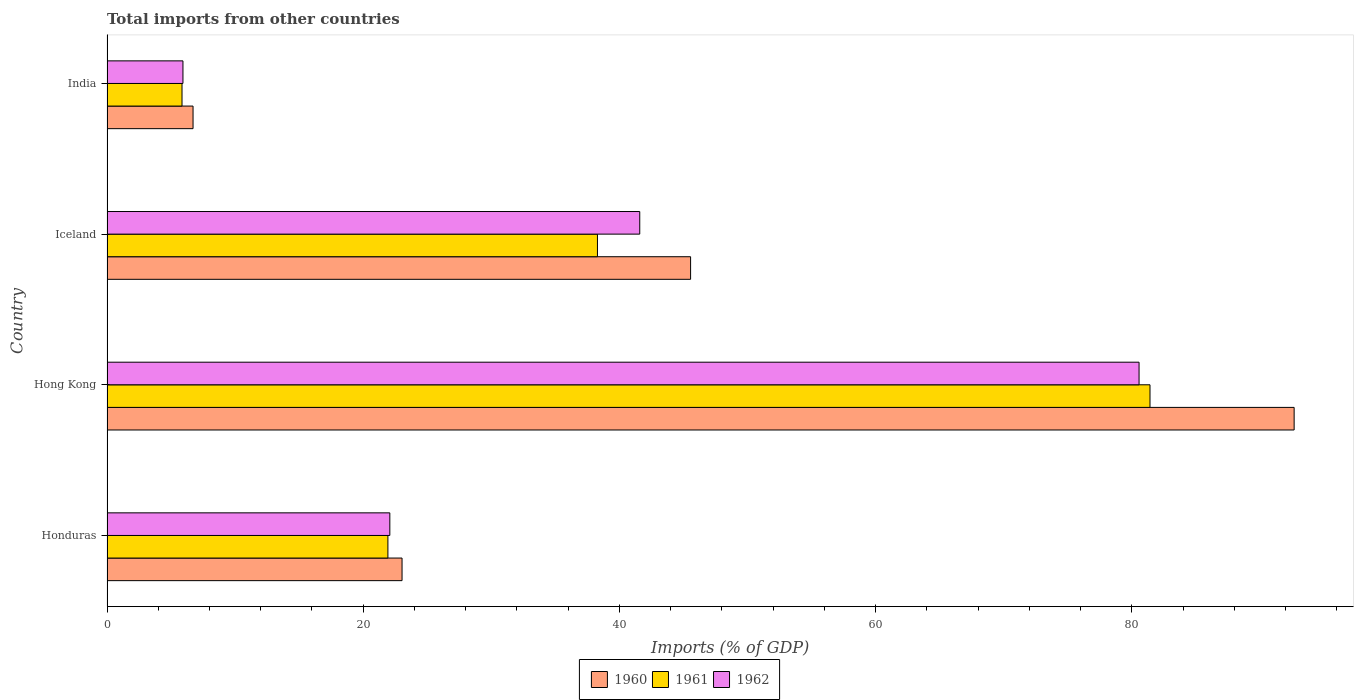How many groups of bars are there?
Offer a very short reply. 4. In how many cases, is the number of bars for a given country not equal to the number of legend labels?
Give a very brief answer. 0. What is the total imports in 1960 in India?
Offer a very short reply. 6.72. Across all countries, what is the maximum total imports in 1960?
Keep it short and to the point. 92.66. Across all countries, what is the minimum total imports in 1961?
Your answer should be compact. 5.85. In which country was the total imports in 1962 maximum?
Offer a terse response. Hong Kong. What is the total total imports in 1961 in the graph?
Your answer should be very brief. 147.48. What is the difference between the total imports in 1962 in Honduras and that in India?
Give a very brief answer. 16.15. What is the difference between the total imports in 1962 in India and the total imports in 1960 in Honduras?
Ensure brevity in your answer.  -17.1. What is the average total imports in 1960 per country?
Your answer should be very brief. 41.99. What is the difference between the total imports in 1961 and total imports in 1962 in India?
Offer a terse response. -0.07. In how many countries, is the total imports in 1960 greater than 36 %?
Provide a short and direct response. 2. What is the ratio of the total imports in 1962 in Honduras to that in Iceland?
Make the answer very short. 0.53. Is the difference between the total imports in 1961 in Hong Kong and Iceland greater than the difference between the total imports in 1962 in Hong Kong and Iceland?
Your answer should be compact. Yes. What is the difference between the highest and the second highest total imports in 1962?
Provide a succinct answer. 38.97. What is the difference between the highest and the lowest total imports in 1962?
Make the answer very short. 74.63. What does the 3rd bar from the top in Hong Kong represents?
Offer a very short reply. 1960. Is it the case that in every country, the sum of the total imports in 1961 and total imports in 1960 is greater than the total imports in 1962?
Your response must be concise. Yes. How many bars are there?
Offer a very short reply. 12. Are all the bars in the graph horizontal?
Give a very brief answer. Yes. How many legend labels are there?
Provide a succinct answer. 3. How are the legend labels stacked?
Ensure brevity in your answer.  Horizontal. What is the title of the graph?
Make the answer very short. Total imports from other countries. Does "1982" appear as one of the legend labels in the graph?
Provide a short and direct response. No. What is the label or title of the X-axis?
Your answer should be very brief. Imports (% of GDP). What is the Imports (% of GDP) in 1960 in Honduras?
Provide a succinct answer. 23.03. What is the Imports (% of GDP) of 1961 in Honduras?
Ensure brevity in your answer.  21.93. What is the Imports (% of GDP) in 1962 in Honduras?
Make the answer very short. 22.08. What is the Imports (% of GDP) in 1960 in Hong Kong?
Keep it short and to the point. 92.66. What is the Imports (% of GDP) of 1961 in Hong Kong?
Ensure brevity in your answer.  81.41. What is the Imports (% of GDP) in 1962 in Hong Kong?
Your response must be concise. 80.56. What is the Imports (% of GDP) of 1960 in Iceland?
Ensure brevity in your answer.  45.55. What is the Imports (% of GDP) of 1961 in Iceland?
Provide a short and direct response. 38.28. What is the Imports (% of GDP) of 1962 in Iceland?
Offer a very short reply. 41.58. What is the Imports (% of GDP) in 1960 in India?
Keep it short and to the point. 6.72. What is the Imports (% of GDP) of 1961 in India?
Your answer should be very brief. 5.85. What is the Imports (% of GDP) of 1962 in India?
Your answer should be compact. 5.93. Across all countries, what is the maximum Imports (% of GDP) in 1960?
Provide a short and direct response. 92.66. Across all countries, what is the maximum Imports (% of GDP) in 1961?
Provide a succinct answer. 81.41. Across all countries, what is the maximum Imports (% of GDP) in 1962?
Your answer should be very brief. 80.56. Across all countries, what is the minimum Imports (% of GDP) in 1960?
Give a very brief answer. 6.72. Across all countries, what is the minimum Imports (% of GDP) of 1961?
Ensure brevity in your answer.  5.85. Across all countries, what is the minimum Imports (% of GDP) in 1962?
Make the answer very short. 5.93. What is the total Imports (% of GDP) of 1960 in the graph?
Provide a short and direct response. 167.96. What is the total Imports (% of GDP) in 1961 in the graph?
Your answer should be compact. 147.48. What is the total Imports (% of GDP) of 1962 in the graph?
Your answer should be compact. 150.15. What is the difference between the Imports (% of GDP) in 1960 in Honduras and that in Hong Kong?
Ensure brevity in your answer.  -69.63. What is the difference between the Imports (% of GDP) of 1961 in Honduras and that in Hong Kong?
Keep it short and to the point. -59.49. What is the difference between the Imports (% of GDP) of 1962 in Honduras and that in Hong Kong?
Your answer should be very brief. -58.48. What is the difference between the Imports (% of GDP) in 1960 in Honduras and that in Iceland?
Your answer should be very brief. -22.52. What is the difference between the Imports (% of GDP) in 1961 in Honduras and that in Iceland?
Make the answer very short. -16.36. What is the difference between the Imports (% of GDP) in 1962 in Honduras and that in Iceland?
Offer a very short reply. -19.51. What is the difference between the Imports (% of GDP) in 1960 in Honduras and that in India?
Your response must be concise. 16.31. What is the difference between the Imports (% of GDP) of 1961 in Honduras and that in India?
Your answer should be very brief. 16.07. What is the difference between the Imports (% of GDP) of 1962 in Honduras and that in India?
Give a very brief answer. 16.15. What is the difference between the Imports (% of GDP) of 1960 in Hong Kong and that in Iceland?
Your response must be concise. 47.11. What is the difference between the Imports (% of GDP) in 1961 in Hong Kong and that in Iceland?
Ensure brevity in your answer.  43.13. What is the difference between the Imports (% of GDP) in 1962 in Hong Kong and that in Iceland?
Give a very brief answer. 38.97. What is the difference between the Imports (% of GDP) in 1960 in Hong Kong and that in India?
Give a very brief answer. 85.95. What is the difference between the Imports (% of GDP) of 1961 in Hong Kong and that in India?
Make the answer very short. 75.56. What is the difference between the Imports (% of GDP) in 1962 in Hong Kong and that in India?
Keep it short and to the point. 74.63. What is the difference between the Imports (% of GDP) in 1960 in Iceland and that in India?
Provide a succinct answer. 38.84. What is the difference between the Imports (% of GDP) in 1961 in Iceland and that in India?
Your answer should be very brief. 32.43. What is the difference between the Imports (% of GDP) of 1962 in Iceland and that in India?
Provide a succinct answer. 35.66. What is the difference between the Imports (% of GDP) in 1960 in Honduras and the Imports (% of GDP) in 1961 in Hong Kong?
Provide a succinct answer. -58.38. What is the difference between the Imports (% of GDP) in 1960 in Honduras and the Imports (% of GDP) in 1962 in Hong Kong?
Provide a succinct answer. -57.53. What is the difference between the Imports (% of GDP) of 1961 in Honduras and the Imports (% of GDP) of 1962 in Hong Kong?
Offer a terse response. -58.63. What is the difference between the Imports (% of GDP) of 1960 in Honduras and the Imports (% of GDP) of 1961 in Iceland?
Keep it short and to the point. -15.25. What is the difference between the Imports (% of GDP) in 1960 in Honduras and the Imports (% of GDP) in 1962 in Iceland?
Your answer should be compact. -18.55. What is the difference between the Imports (% of GDP) of 1961 in Honduras and the Imports (% of GDP) of 1962 in Iceland?
Your response must be concise. -19.66. What is the difference between the Imports (% of GDP) in 1960 in Honduras and the Imports (% of GDP) in 1961 in India?
Your answer should be compact. 17.18. What is the difference between the Imports (% of GDP) of 1960 in Honduras and the Imports (% of GDP) of 1962 in India?
Your answer should be very brief. 17.1. What is the difference between the Imports (% of GDP) of 1961 in Honduras and the Imports (% of GDP) of 1962 in India?
Provide a short and direct response. 16. What is the difference between the Imports (% of GDP) in 1960 in Hong Kong and the Imports (% of GDP) in 1961 in Iceland?
Keep it short and to the point. 54.38. What is the difference between the Imports (% of GDP) of 1960 in Hong Kong and the Imports (% of GDP) of 1962 in Iceland?
Your response must be concise. 51.08. What is the difference between the Imports (% of GDP) in 1961 in Hong Kong and the Imports (% of GDP) in 1962 in Iceland?
Ensure brevity in your answer.  39.83. What is the difference between the Imports (% of GDP) in 1960 in Hong Kong and the Imports (% of GDP) in 1961 in India?
Give a very brief answer. 86.81. What is the difference between the Imports (% of GDP) in 1960 in Hong Kong and the Imports (% of GDP) in 1962 in India?
Provide a succinct answer. 86.74. What is the difference between the Imports (% of GDP) of 1961 in Hong Kong and the Imports (% of GDP) of 1962 in India?
Your answer should be compact. 75.49. What is the difference between the Imports (% of GDP) in 1960 in Iceland and the Imports (% of GDP) in 1961 in India?
Keep it short and to the point. 39.7. What is the difference between the Imports (% of GDP) of 1960 in Iceland and the Imports (% of GDP) of 1962 in India?
Offer a very short reply. 39.63. What is the difference between the Imports (% of GDP) in 1961 in Iceland and the Imports (% of GDP) in 1962 in India?
Your response must be concise. 32.35. What is the average Imports (% of GDP) in 1960 per country?
Your response must be concise. 41.99. What is the average Imports (% of GDP) in 1961 per country?
Provide a short and direct response. 36.87. What is the average Imports (% of GDP) in 1962 per country?
Make the answer very short. 37.54. What is the difference between the Imports (% of GDP) of 1960 and Imports (% of GDP) of 1961 in Honduras?
Keep it short and to the point. 1.1. What is the difference between the Imports (% of GDP) in 1960 and Imports (% of GDP) in 1962 in Honduras?
Provide a short and direct response. 0.95. What is the difference between the Imports (% of GDP) in 1961 and Imports (% of GDP) in 1962 in Honduras?
Your answer should be compact. -0.15. What is the difference between the Imports (% of GDP) in 1960 and Imports (% of GDP) in 1961 in Hong Kong?
Offer a very short reply. 11.25. What is the difference between the Imports (% of GDP) in 1960 and Imports (% of GDP) in 1962 in Hong Kong?
Offer a terse response. 12.1. What is the difference between the Imports (% of GDP) in 1961 and Imports (% of GDP) in 1962 in Hong Kong?
Ensure brevity in your answer.  0.85. What is the difference between the Imports (% of GDP) in 1960 and Imports (% of GDP) in 1961 in Iceland?
Provide a short and direct response. 7.27. What is the difference between the Imports (% of GDP) in 1960 and Imports (% of GDP) in 1962 in Iceland?
Provide a succinct answer. 3.97. What is the difference between the Imports (% of GDP) in 1961 and Imports (% of GDP) in 1962 in Iceland?
Keep it short and to the point. -3.3. What is the difference between the Imports (% of GDP) of 1960 and Imports (% of GDP) of 1961 in India?
Provide a succinct answer. 0.86. What is the difference between the Imports (% of GDP) in 1960 and Imports (% of GDP) in 1962 in India?
Your response must be concise. 0.79. What is the difference between the Imports (% of GDP) of 1961 and Imports (% of GDP) of 1962 in India?
Your response must be concise. -0.07. What is the ratio of the Imports (% of GDP) in 1960 in Honduras to that in Hong Kong?
Keep it short and to the point. 0.25. What is the ratio of the Imports (% of GDP) of 1961 in Honduras to that in Hong Kong?
Your answer should be compact. 0.27. What is the ratio of the Imports (% of GDP) in 1962 in Honduras to that in Hong Kong?
Provide a short and direct response. 0.27. What is the ratio of the Imports (% of GDP) of 1960 in Honduras to that in Iceland?
Provide a succinct answer. 0.51. What is the ratio of the Imports (% of GDP) of 1961 in Honduras to that in Iceland?
Your answer should be compact. 0.57. What is the ratio of the Imports (% of GDP) of 1962 in Honduras to that in Iceland?
Provide a short and direct response. 0.53. What is the ratio of the Imports (% of GDP) in 1960 in Honduras to that in India?
Ensure brevity in your answer.  3.43. What is the ratio of the Imports (% of GDP) of 1961 in Honduras to that in India?
Provide a short and direct response. 3.74. What is the ratio of the Imports (% of GDP) in 1962 in Honduras to that in India?
Keep it short and to the point. 3.72. What is the ratio of the Imports (% of GDP) of 1960 in Hong Kong to that in Iceland?
Make the answer very short. 2.03. What is the ratio of the Imports (% of GDP) in 1961 in Hong Kong to that in Iceland?
Ensure brevity in your answer.  2.13. What is the ratio of the Imports (% of GDP) in 1962 in Hong Kong to that in Iceland?
Your response must be concise. 1.94. What is the ratio of the Imports (% of GDP) in 1960 in Hong Kong to that in India?
Offer a very short reply. 13.8. What is the ratio of the Imports (% of GDP) of 1961 in Hong Kong to that in India?
Your answer should be compact. 13.91. What is the ratio of the Imports (% of GDP) in 1962 in Hong Kong to that in India?
Offer a terse response. 13.59. What is the ratio of the Imports (% of GDP) in 1960 in Iceland to that in India?
Your response must be concise. 6.78. What is the ratio of the Imports (% of GDP) in 1961 in Iceland to that in India?
Give a very brief answer. 6.54. What is the ratio of the Imports (% of GDP) in 1962 in Iceland to that in India?
Keep it short and to the point. 7.01. What is the difference between the highest and the second highest Imports (% of GDP) of 1960?
Offer a very short reply. 47.11. What is the difference between the highest and the second highest Imports (% of GDP) in 1961?
Your answer should be compact. 43.13. What is the difference between the highest and the second highest Imports (% of GDP) in 1962?
Your response must be concise. 38.97. What is the difference between the highest and the lowest Imports (% of GDP) in 1960?
Offer a terse response. 85.95. What is the difference between the highest and the lowest Imports (% of GDP) in 1961?
Provide a succinct answer. 75.56. What is the difference between the highest and the lowest Imports (% of GDP) in 1962?
Offer a very short reply. 74.63. 